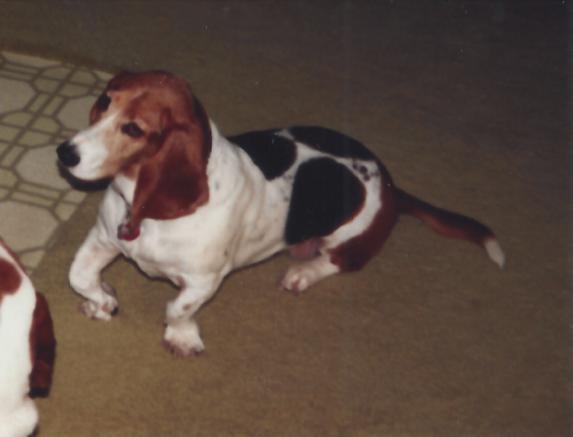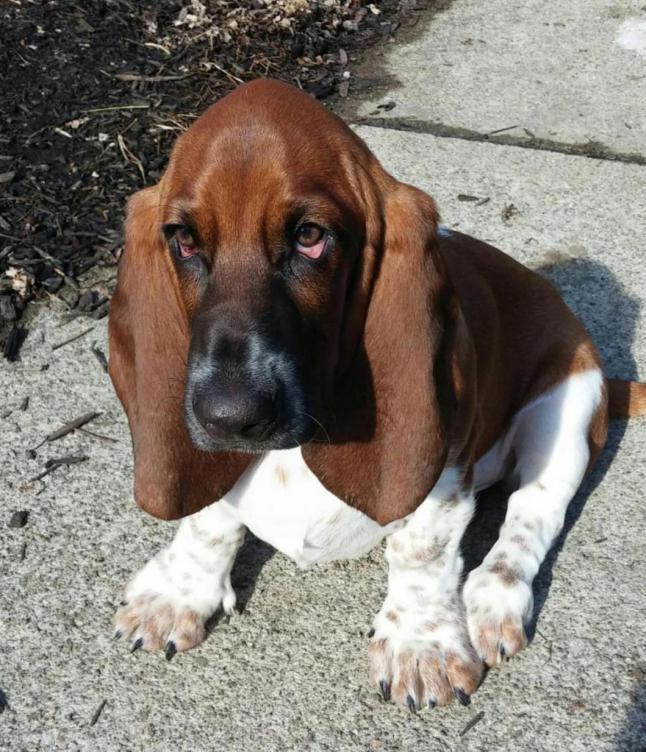The first image is the image on the left, the second image is the image on the right. Examine the images to the left and right. Is the description "At least one dog is standing on the grass." accurate? Answer yes or no. No. The first image is the image on the left, the second image is the image on the right. Considering the images on both sides, is "a dog is standing in the grass facing left'" valid? Answer yes or no. No. 